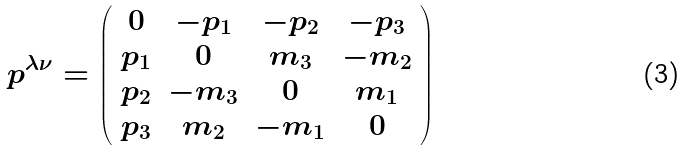Convert formula to latex. <formula><loc_0><loc_0><loc_500><loc_500>p ^ { \lambda \nu } = \left ( \begin{array} [ c ] { c c c c } 0 & - p _ { 1 } & - p _ { 2 } & - p _ { 3 } \\ p _ { 1 } & 0 & m _ { 3 } & - m _ { 2 } \\ p _ { 2 } & - m _ { 3 } & 0 & m _ { 1 } \\ p _ { 3 } & m _ { 2 } & - m _ { 1 } & 0 \end{array} \right )</formula> 